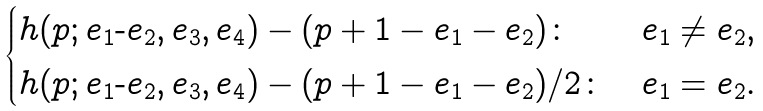<formula> <loc_0><loc_0><loc_500><loc_500>\begin{cases} h ( p ; e _ { 1 } \text {-} e _ { 2 } , e _ { 3 } , e _ { 4 } ) - ( p + 1 - e _ { 1 } - e _ { 2 } ) \colon & e _ { 1 } \neq e _ { 2 } , \\ h ( p ; e _ { 1 } \text {-} e _ { 2 } , e _ { 3 } , e _ { 4 } ) - ( p + 1 - e _ { 1 } - e _ { 2 } ) / 2 \colon & e _ { 1 } = e _ { 2 } . \end{cases}</formula> 